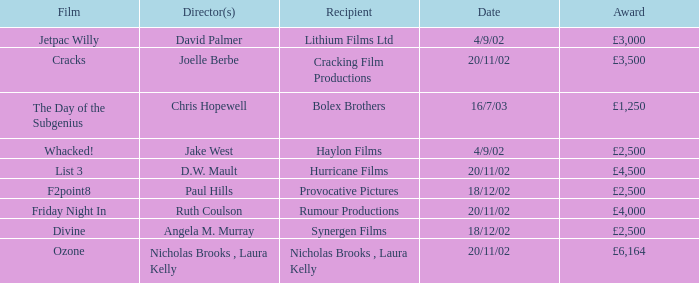Who directed a film for Cracking Film Productions? Joelle Berbe. 